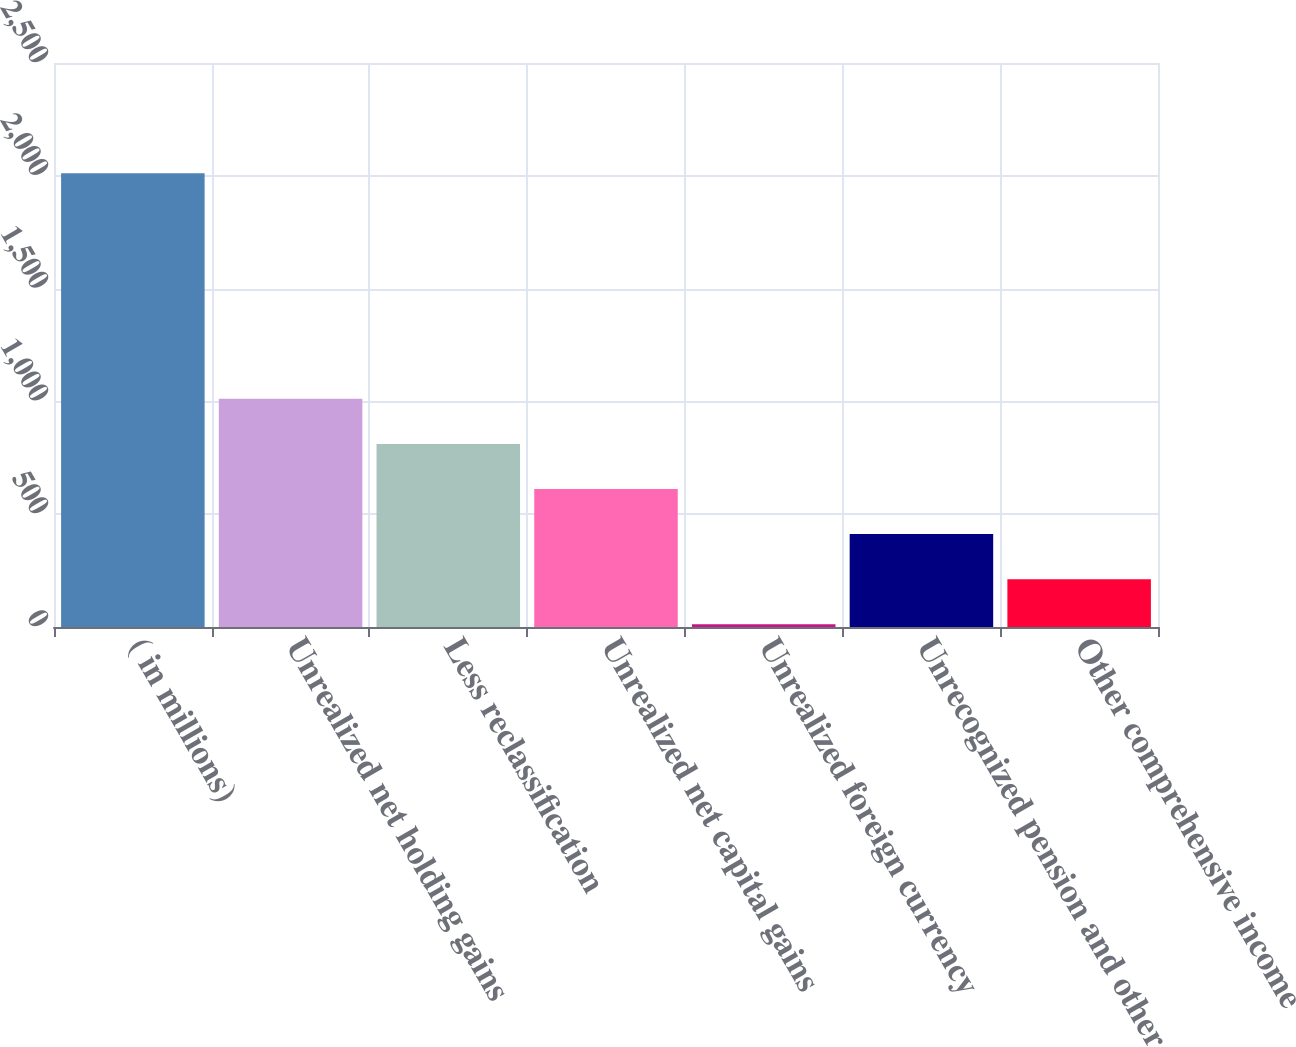Convert chart to OTSL. <chart><loc_0><loc_0><loc_500><loc_500><bar_chart><fcel>( in millions)<fcel>Unrealized net holding gains<fcel>Less reclassification<fcel>Unrealized net capital gains<fcel>Unrealized foreign currency<fcel>Unrecognized pension and other<fcel>Other comprehensive income<nl><fcel>2011<fcel>1011.5<fcel>811.6<fcel>611.7<fcel>12<fcel>411.8<fcel>211.9<nl></chart> 